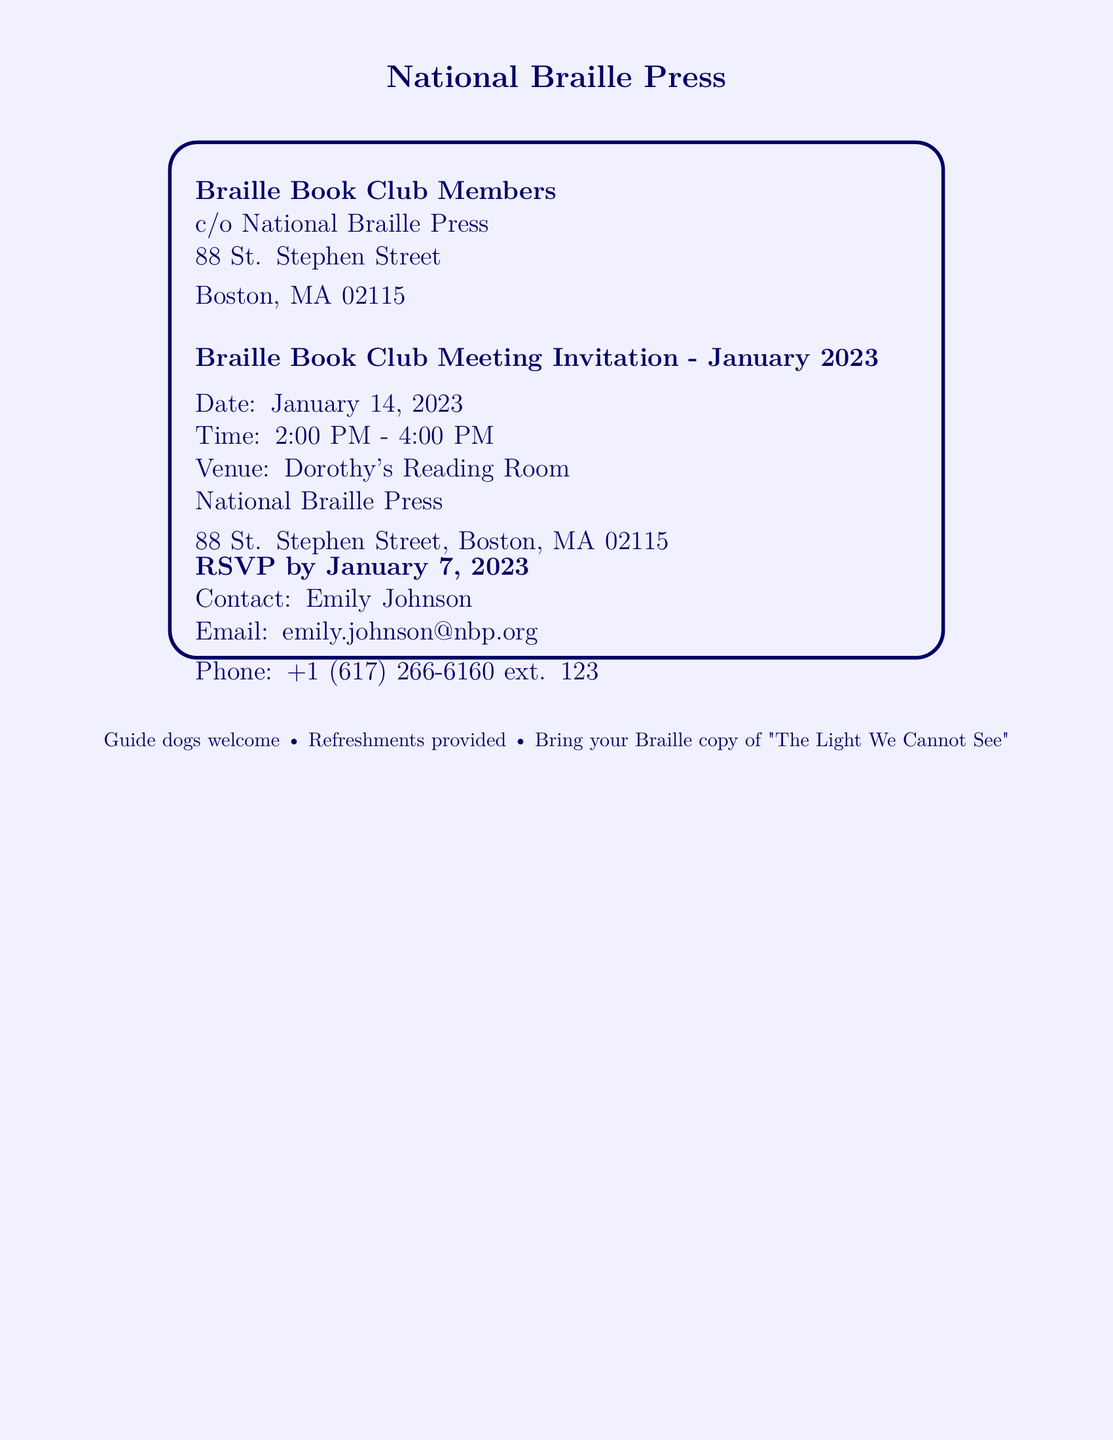What is the date of the meeting? The date of the meeting is specifically mentioned in the document as January 14, 2023.
Answer: January 14, 2023 What time does the meeting start? The start time of the meeting is stated as 2:00 PM in the document.
Answer: 2:00 PM Where is the venue located? The venue is listed in the document as Dorothy's Reading Room, National Braille Press.
Answer: Dorothy's Reading Room, National Braille Press Who should RSVP? The document mentions Emily Johnson as the contact for RSVPs.
Answer: Emily Johnson What is the RSVP deadline? The document specifies that RSVPs should be made by January 7, 2023.
Answer: January 7, 2023 What refreshments will be provided? The document states that refreshments will be provided during the meeting.
Answer: Refreshments provided What book should members bring? The document requests members to bring their Braille copy of "The Light We Cannot See."
Answer: "The Light We Cannot See" What phone number can be used for inquiries? The document provides a contact phone number as +1 (617) 266-6160 ext. 123.
Answer: +1 (617) 266-6160 ext. 123 